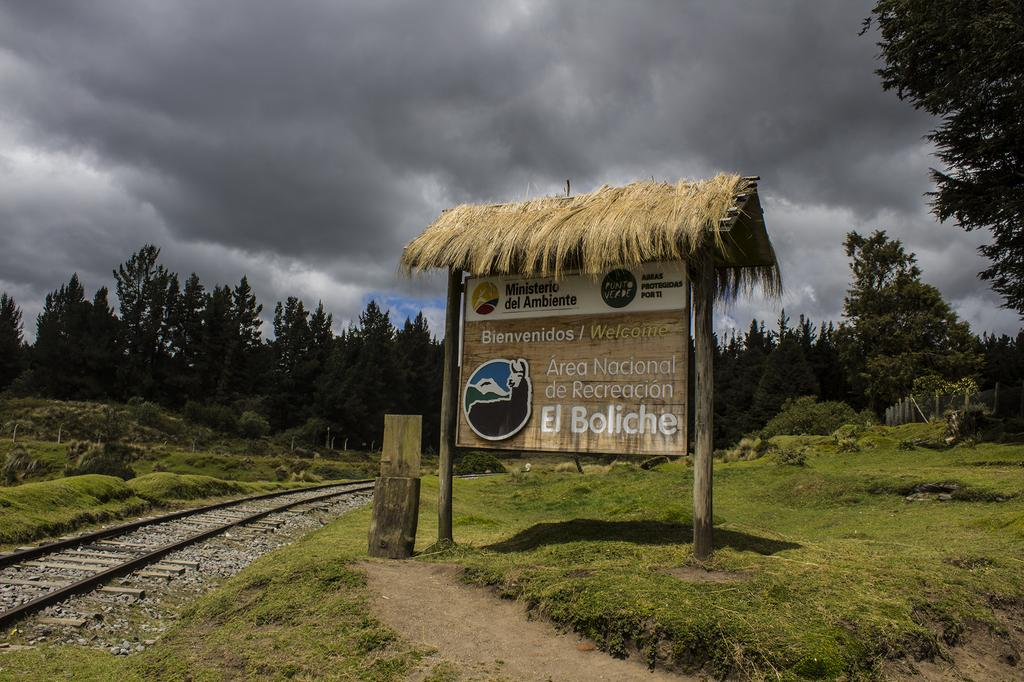What is the main feature of the image? There is a railway track in the image. What is located beside the railway track? There is a board beside the railway track. What can be seen on the ground near the railway track? There is a wooden object on the ground. What can be seen in the background of the image? There are trees and the sky visible in the background of the image. What type of rice is being cooked in the pot on the board? There is no pot or rice present in the image; it only features a railway track, a board, a wooden object, trees, and the sky. 